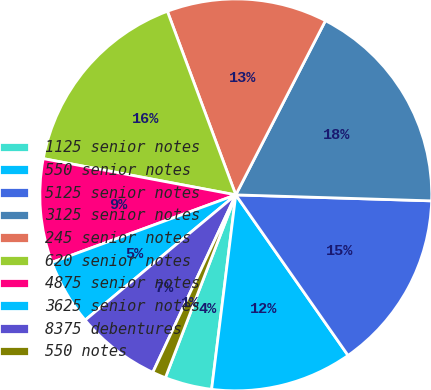Convert chart. <chart><loc_0><loc_0><loc_500><loc_500><pie_chart><fcel>1125 senior notes<fcel>550 senior notes<fcel>5125 senior notes<fcel>3125 senior notes<fcel>245 senior notes<fcel>620 senior notes<fcel>4875 senior notes<fcel>3625 senior notes<fcel>8375 debentures<fcel>550 notes<nl><fcel>3.88%<fcel>11.68%<fcel>14.8%<fcel>17.92%<fcel>13.24%<fcel>16.36%<fcel>8.56%<fcel>5.44%<fcel>7.0%<fcel>1.11%<nl></chart> 